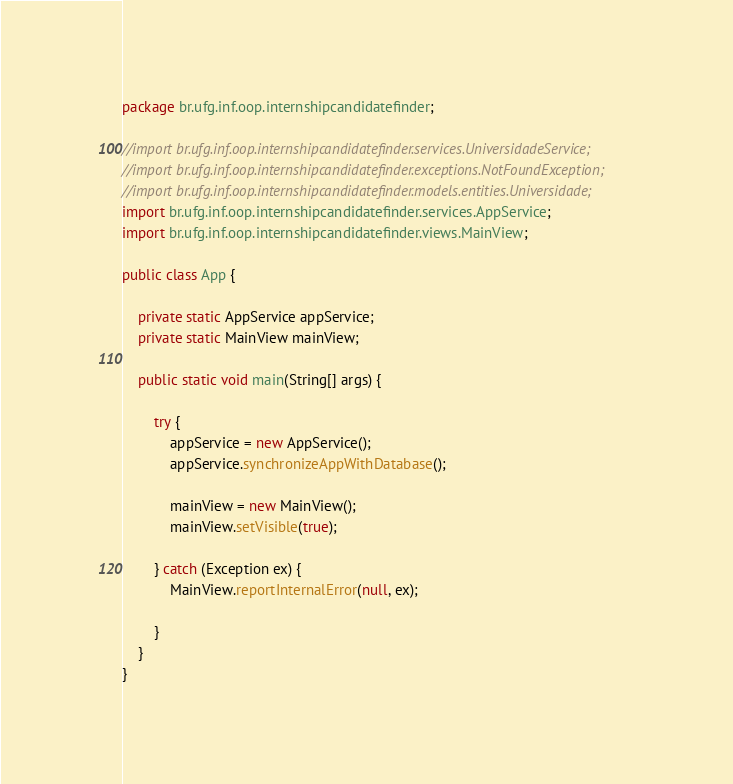Convert code to text. <code><loc_0><loc_0><loc_500><loc_500><_Java_>package br.ufg.inf.oop.internshipcandidatefinder;

//import br.ufg.inf.oop.internshipcandidatefinder.services.UniversidadeService;
//import br.ufg.inf.oop.internshipcandidatefinder.exceptions.NotFoundException;
//import br.ufg.inf.oop.internshipcandidatefinder.models.entities.Universidade;
import br.ufg.inf.oop.internshipcandidatefinder.services.AppService;
import br.ufg.inf.oop.internshipcandidatefinder.views.MainView;

public class App {

    private static AppService appService;
    private static MainView mainView;

    public static void main(String[] args) {

        try {
            appService = new AppService();
            appService.synchronizeAppWithDatabase();

            mainView = new MainView();
            mainView.setVisible(true);

        } catch (Exception ex) {
            MainView.reportInternalError(null, ex);

        }
    }
}
</code> 